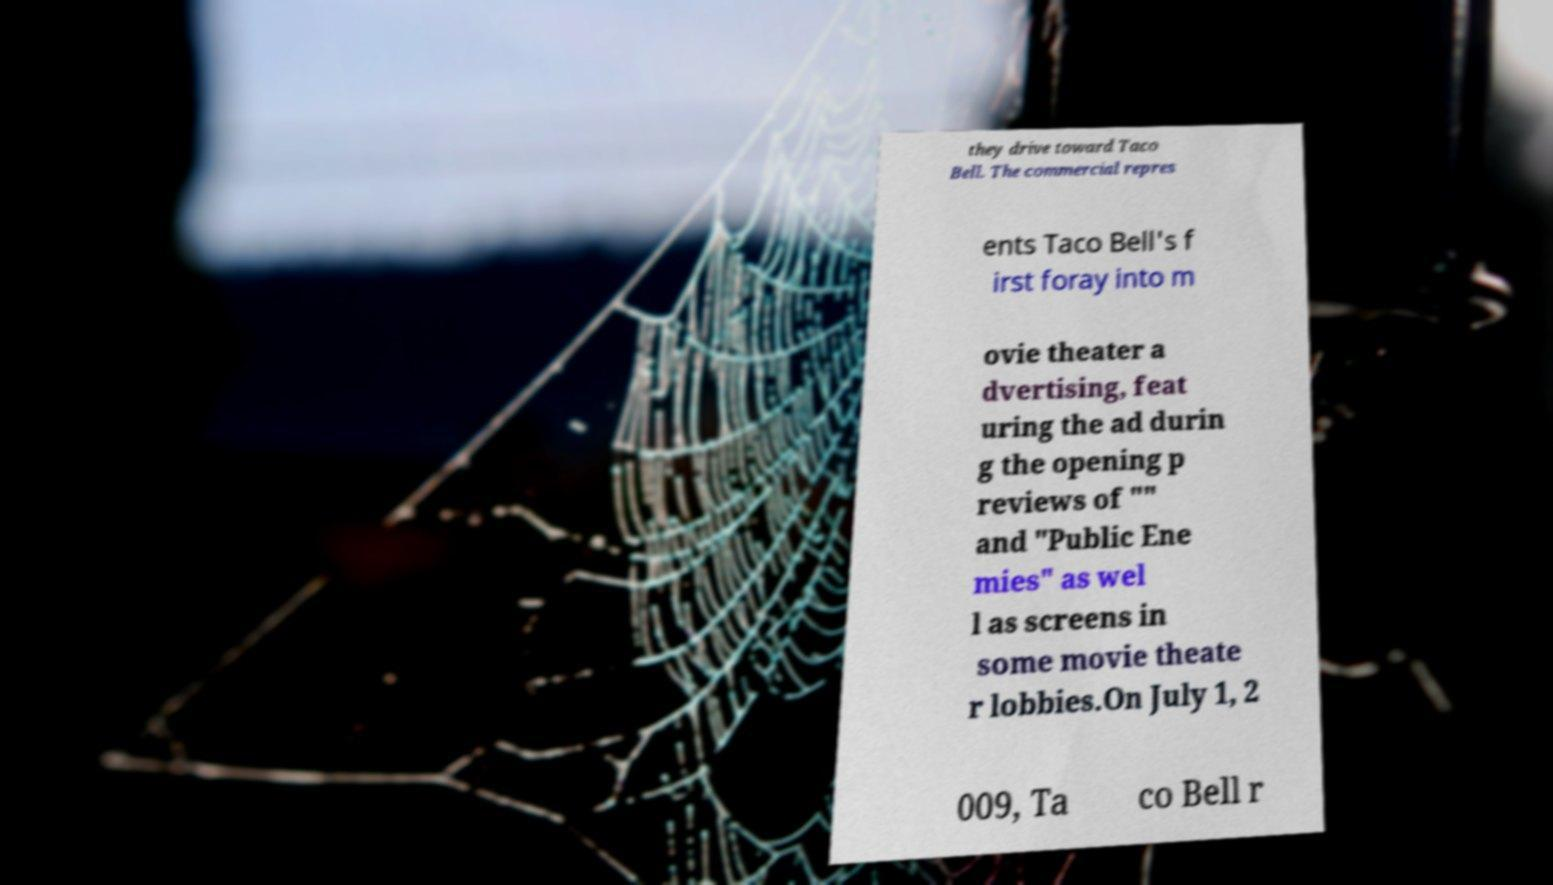I need the written content from this picture converted into text. Can you do that? they drive toward Taco Bell. The commercial repres ents Taco Bell's f irst foray into m ovie theater a dvertising, feat uring the ad durin g the opening p reviews of "" and "Public Ene mies" as wel l as screens in some movie theate r lobbies.On July 1, 2 009, Ta co Bell r 